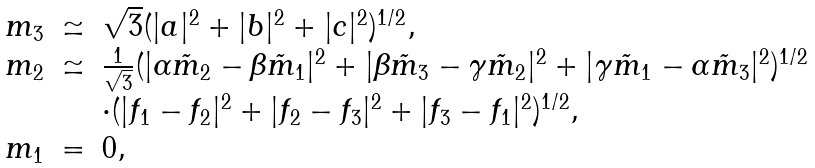Convert formula to latex. <formula><loc_0><loc_0><loc_500><loc_500>\begin{array} { r c l } m _ { 3 } & \simeq & \sqrt { 3 } ( | a | ^ { 2 } + | b | ^ { 2 } + | c | ^ { 2 } ) ^ { 1 / 2 } , \\ m _ { 2 } & \simeq & \frac { 1 } { \sqrt { 3 } } ( | \alpha \tilde { m } _ { 2 } - \beta \tilde { m } _ { 1 } | ^ { 2 } + | \beta \tilde { m } _ { 3 } - \gamma \tilde { m } _ { 2 } | ^ { 2 } + | \gamma \tilde { m } _ { 1 } - \alpha \tilde { m } _ { 3 } | ^ { 2 } ) ^ { 1 / 2 } \\ & & \cdot ( | f _ { 1 } - f _ { 2 } | ^ { 2 } + | f _ { 2 } - f _ { 3 } | ^ { 2 } + | f _ { 3 } - f _ { 1 } | ^ { 2 } ) ^ { 1 / 2 } , \\ m _ { 1 } & = & 0 , \end{array}</formula> 